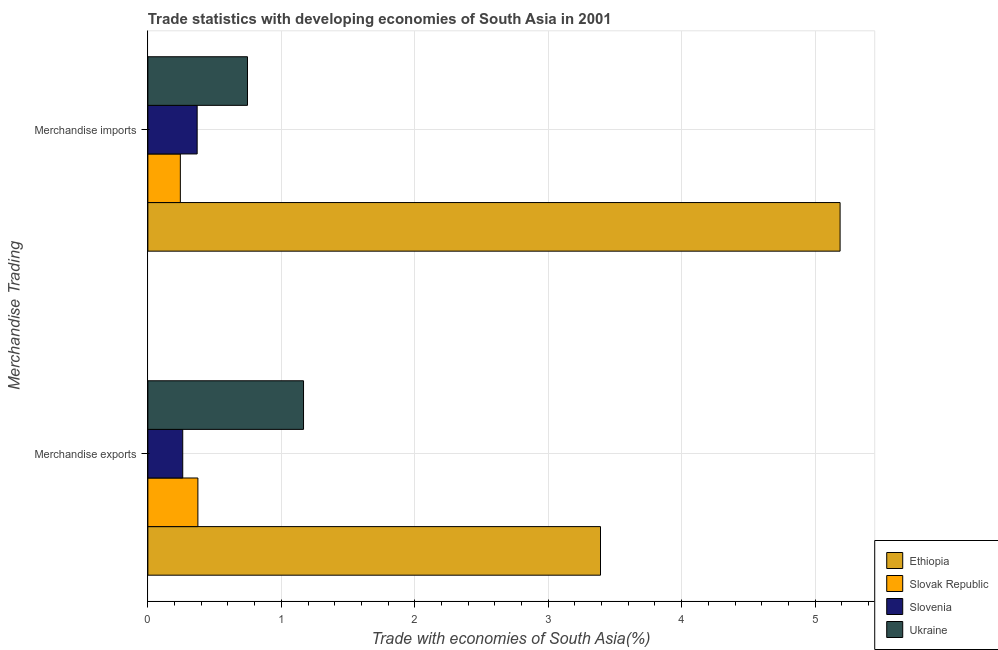How many different coloured bars are there?
Make the answer very short. 4. How many groups of bars are there?
Ensure brevity in your answer.  2. Are the number of bars per tick equal to the number of legend labels?
Ensure brevity in your answer.  Yes. Are the number of bars on each tick of the Y-axis equal?
Keep it short and to the point. Yes. What is the merchandise exports in Slovenia?
Offer a very short reply. 0.26. Across all countries, what is the maximum merchandise exports?
Provide a succinct answer. 3.39. Across all countries, what is the minimum merchandise imports?
Your answer should be very brief. 0.24. In which country was the merchandise exports maximum?
Your answer should be very brief. Ethiopia. In which country was the merchandise exports minimum?
Offer a terse response. Slovenia. What is the total merchandise exports in the graph?
Give a very brief answer. 5.19. What is the difference between the merchandise imports in Slovak Republic and that in Slovenia?
Your answer should be compact. -0.13. What is the difference between the merchandise exports in Slovak Republic and the merchandise imports in Ethiopia?
Make the answer very short. -4.81. What is the average merchandise exports per country?
Keep it short and to the point. 1.3. What is the difference between the merchandise imports and merchandise exports in Ethiopia?
Provide a succinct answer. 1.8. In how many countries, is the merchandise imports greater than 1.4 %?
Your answer should be very brief. 1. What is the ratio of the merchandise exports in Slovenia to that in Ethiopia?
Ensure brevity in your answer.  0.08. In how many countries, is the merchandise exports greater than the average merchandise exports taken over all countries?
Provide a succinct answer. 1. What does the 4th bar from the top in Merchandise exports represents?
Give a very brief answer. Ethiopia. What does the 1st bar from the bottom in Merchandise exports represents?
Make the answer very short. Ethiopia. How many bars are there?
Your response must be concise. 8. How many countries are there in the graph?
Give a very brief answer. 4. How are the legend labels stacked?
Your answer should be compact. Vertical. What is the title of the graph?
Offer a very short reply. Trade statistics with developing economies of South Asia in 2001. Does "Sierra Leone" appear as one of the legend labels in the graph?
Your response must be concise. No. What is the label or title of the X-axis?
Offer a very short reply. Trade with economies of South Asia(%). What is the label or title of the Y-axis?
Give a very brief answer. Merchandise Trading. What is the Trade with economies of South Asia(%) in Ethiopia in Merchandise exports?
Give a very brief answer. 3.39. What is the Trade with economies of South Asia(%) in Slovak Republic in Merchandise exports?
Give a very brief answer. 0.37. What is the Trade with economies of South Asia(%) of Slovenia in Merchandise exports?
Give a very brief answer. 0.26. What is the Trade with economies of South Asia(%) in Ukraine in Merchandise exports?
Make the answer very short. 1.17. What is the Trade with economies of South Asia(%) in Ethiopia in Merchandise imports?
Provide a succinct answer. 5.19. What is the Trade with economies of South Asia(%) in Slovak Republic in Merchandise imports?
Your answer should be very brief. 0.24. What is the Trade with economies of South Asia(%) of Slovenia in Merchandise imports?
Keep it short and to the point. 0.37. What is the Trade with economies of South Asia(%) in Ukraine in Merchandise imports?
Make the answer very short. 0.75. Across all Merchandise Trading, what is the maximum Trade with economies of South Asia(%) in Ethiopia?
Offer a terse response. 5.19. Across all Merchandise Trading, what is the maximum Trade with economies of South Asia(%) in Slovak Republic?
Keep it short and to the point. 0.37. Across all Merchandise Trading, what is the maximum Trade with economies of South Asia(%) in Slovenia?
Make the answer very short. 0.37. Across all Merchandise Trading, what is the maximum Trade with economies of South Asia(%) in Ukraine?
Your answer should be very brief. 1.17. Across all Merchandise Trading, what is the minimum Trade with economies of South Asia(%) in Ethiopia?
Your response must be concise. 3.39. Across all Merchandise Trading, what is the minimum Trade with economies of South Asia(%) in Slovak Republic?
Offer a terse response. 0.24. Across all Merchandise Trading, what is the minimum Trade with economies of South Asia(%) of Slovenia?
Provide a short and direct response. 0.26. Across all Merchandise Trading, what is the minimum Trade with economies of South Asia(%) of Ukraine?
Your response must be concise. 0.75. What is the total Trade with economies of South Asia(%) of Ethiopia in the graph?
Provide a succinct answer. 8.58. What is the total Trade with economies of South Asia(%) of Slovak Republic in the graph?
Your answer should be very brief. 0.62. What is the total Trade with economies of South Asia(%) in Slovenia in the graph?
Keep it short and to the point. 0.63. What is the total Trade with economies of South Asia(%) in Ukraine in the graph?
Your answer should be compact. 1.91. What is the difference between the Trade with economies of South Asia(%) of Ethiopia in Merchandise exports and that in Merchandise imports?
Provide a short and direct response. -1.8. What is the difference between the Trade with economies of South Asia(%) of Slovak Republic in Merchandise exports and that in Merchandise imports?
Give a very brief answer. 0.13. What is the difference between the Trade with economies of South Asia(%) of Slovenia in Merchandise exports and that in Merchandise imports?
Provide a succinct answer. -0.11. What is the difference between the Trade with economies of South Asia(%) of Ukraine in Merchandise exports and that in Merchandise imports?
Provide a succinct answer. 0.42. What is the difference between the Trade with economies of South Asia(%) of Ethiopia in Merchandise exports and the Trade with economies of South Asia(%) of Slovak Republic in Merchandise imports?
Offer a very short reply. 3.15. What is the difference between the Trade with economies of South Asia(%) in Ethiopia in Merchandise exports and the Trade with economies of South Asia(%) in Slovenia in Merchandise imports?
Keep it short and to the point. 3.02. What is the difference between the Trade with economies of South Asia(%) in Ethiopia in Merchandise exports and the Trade with economies of South Asia(%) in Ukraine in Merchandise imports?
Ensure brevity in your answer.  2.65. What is the difference between the Trade with economies of South Asia(%) of Slovak Republic in Merchandise exports and the Trade with economies of South Asia(%) of Slovenia in Merchandise imports?
Offer a very short reply. 0.01. What is the difference between the Trade with economies of South Asia(%) in Slovak Republic in Merchandise exports and the Trade with economies of South Asia(%) in Ukraine in Merchandise imports?
Your response must be concise. -0.37. What is the difference between the Trade with economies of South Asia(%) of Slovenia in Merchandise exports and the Trade with economies of South Asia(%) of Ukraine in Merchandise imports?
Your answer should be very brief. -0.49. What is the average Trade with economies of South Asia(%) in Ethiopia per Merchandise Trading?
Your answer should be very brief. 4.29. What is the average Trade with economies of South Asia(%) of Slovak Republic per Merchandise Trading?
Your answer should be compact. 0.31. What is the average Trade with economies of South Asia(%) of Slovenia per Merchandise Trading?
Your answer should be compact. 0.32. What is the average Trade with economies of South Asia(%) in Ukraine per Merchandise Trading?
Give a very brief answer. 0.96. What is the difference between the Trade with economies of South Asia(%) of Ethiopia and Trade with economies of South Asia(%) of Slovak Republic in Merchandise exports?
Your answer should be very brief. 3.02. What is the difference between the Trade with economies of South Asia(%) of Ethiopia and Trade with economies of South Asia(%) of Slovenia in Merchandise exports?
Make the answer very short. 3.13. What is the difference between the Trade with economies of South Asia(%) of Ethiopia and Trade with economies of South Asia(%) of Ukraine in Merchandise exports?
Give a very brief answer. 2.23. What is the difference between the Trade with economies of South Asia(%) of Slovak Republic and Trade with economies of South Asia(%) of Slovenia in Merchandise exports?
Your answer should be compact. 0.11. What is the difference between the Trade with economies of South Asia(%) of Slovak Republic and Trade with economies of South Asia(%) of Ukraine in Merchandise exports?
Your answer should be compact. -0.79. What is the difference between the Trade with economies of South Asia(%) in Slovenia and Trade with economies of South Asia(%) in Ukraine in Merchandise exports?
Your answer should be compact. -0.91. What is the difference between the Trade with economies of South Asia(%) in Ethiopia and Trade with economies of South Asia(%) in Slovak Republic in Merchandise imports?
Offer a very short reply. 4.94. What is the difference between the Trade with economies of South Asia(%) of Ethiopia and Trade with economies of South Asia(%) of Slovenia in Merchandise imports?
Offer a very short reply. 4.82. What is the difference between the Trade with economies of South Asia(%) of Ethiopia and Trade with economies of South Asia(%) of Ukraine in Merchandise imports?
Offer a terse response. 4.44. What is the difference between the Trade with economies of South Asia(%) in Slovak Republic and Trade with economies of South Asia(%) in Slovenia in Merchandise imports?
Your answer should be compact. -0.13. What is the difference between the Trade with economies of South Asia(%) in Slovak Republic and Trade with economies of South Asia(%) in Ukraine in Merchandise imports?
Your answer should be compact. -0.5. What is the difference between the Trade with economies of South Asia(%) in Slovenia and Trade with economies of South Asia(%) in Ukraine in Merchandise imports?
Your answer should be compact. -0.38. What is the ratio of the Trade with economies of South Asia(%) in Ethiopia in Merchandise exports to that in Merchandise imports?
Your response must be concise. 0.65. What is the ratio of the Trade with economies of South Asia(%) of Slovak Republic in Merchandise exports to that in Merchandise imports?
Make the answer very short. 1.54. What is the ratio of the Trade with economies of South Asia(%) of Slovenia in Merchandise exports to that in Merchandise imports?
Offer a terse response. 0.71. What is the ratio of the Trade with economies of South Asia(%) in Ukraine in Merchandise exports to that in Merchandise imports?
Offer a terse response. 1.56. What is the difference between the highest and the second highest Trade with economies of South Asia(%) of Ethiopia?
Ensure brevity in your answer.  1.8. What is the difference between the highest and the second highest Trade with economies of South Asia(%) in Slovak Republic?
Keep it short and to the point. 0.13. What is the difference between the highest and the second highest Trade with economies of South Asia(%) of Slovenia?
Keep it short and to the point. 0.11. What is the difference between the highest and the second highest Trade with economies of South Asia(%) in Ukraine?
Offer a very short reply. 0.42. What is the difference between the highest and the lowest Trade with economies of South Asia(%) in Ethiopia?
Your answer should be compact. 1.8. What is the difference between the highest and the lowest Trade with economies of South Asia(%) in Slovak Republic?
Your answer should be very brief. 0.13. What is the difference between the highest and the lowest Trade with economies of South Asia(%) in Slovenia?
Provide a short and direct response. 0.11. What is the difference between the highest and the lowest Trade with economies of South Asia(%) in Ukraine?
Your response must be concise. 0.42. 